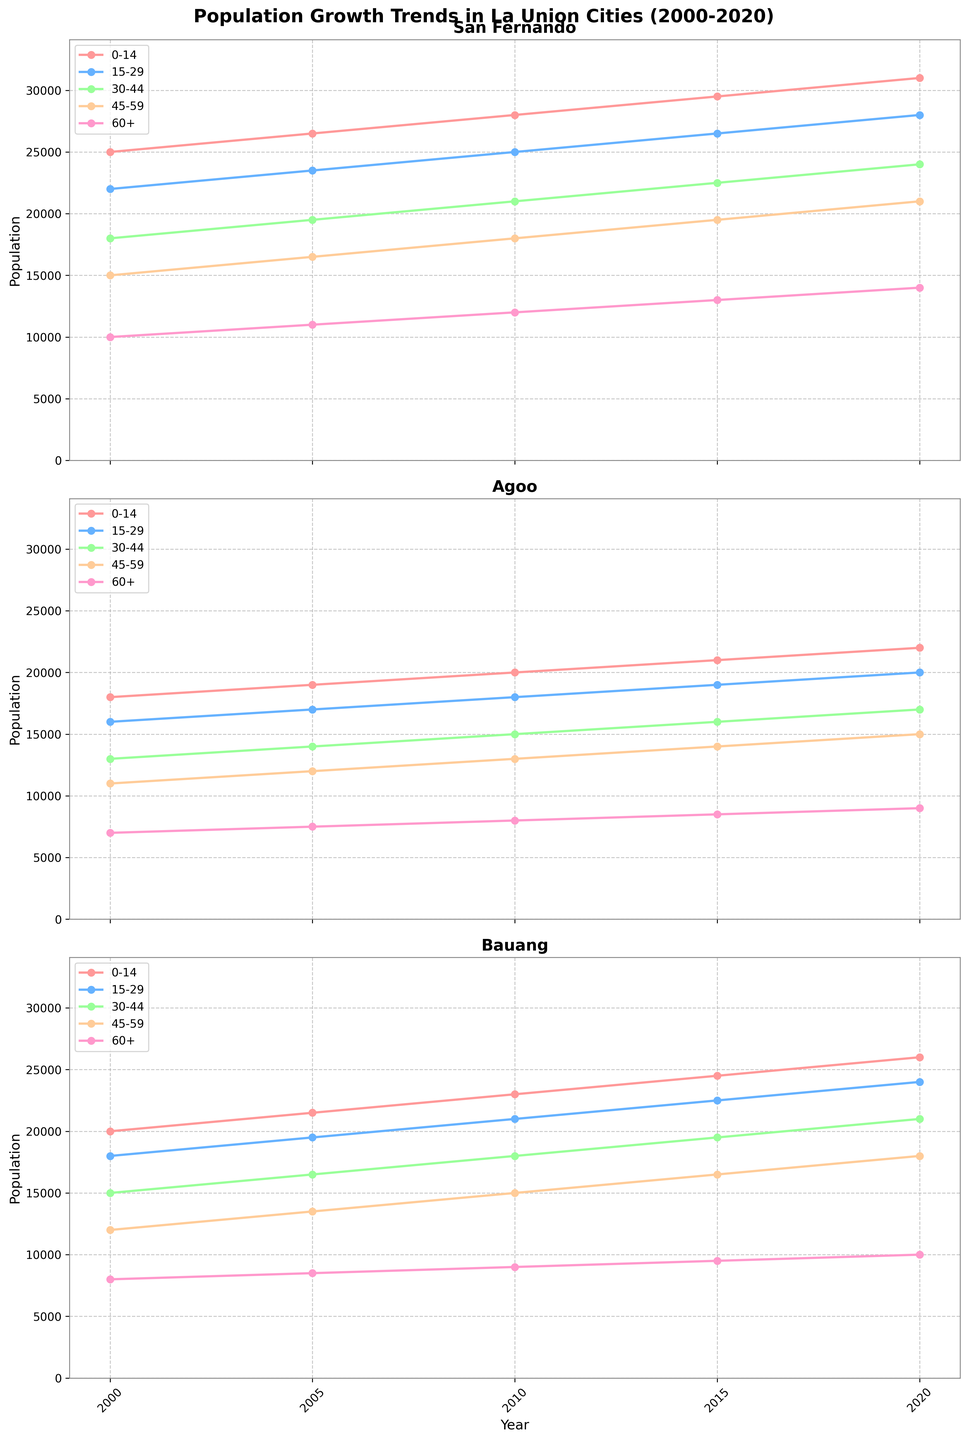How has the population of age group 15-29 in San Fernando changed from 2000 to 2020? To determine the change in population, find the population of age group 15-29 in both 2000 and 2020, and then compute the difference. The population for 15-29 age group in 2000 is 22,000. The population for 15-29 age group in 2020 is 28,000. The increase is 28,000 - 22,000 = 6,000.
Answer: 6,000 Which city had the highest population for the 0-14 age group in 2015? Look at the subplot for 2015 and compare the heights of the lines representing the 0-14 age group for all cities. San Fernando has the highest population for the 0-14 age group in 2015, with 29,500.
Answer: San Fernando For the age group 60+, compare the population growth in Agoo and Bauang from 2000 to 2020. To compare the growth, calculate the difference for each city.
- Agoo: 9,000 in 2020 and 7,000 in 2000, thus an increase of 9,000 - 7,000 = 2,000.
- Bauang: 10,000 in 2020 and 8,000 in 2000, thus an increase of 10,000 - 8,000 = 2,000.
Both cities had the same population growth.
Answer: Same Which age group in Bauang showed the greatest population increase from 2000 to 2020? Calculate the population increases for each age group in Bauang:
- 0-14: 26,000 - 20,000 = 6,000
- 15-29: 24,000 - 18,000 = 6,000
- 30-44: 21,000 - 15,000 = 6,000
- 45-59: 18,000 - 12,000 = 6,000
- 60+: 10,000 - 8,000 = 2,000
The groups 0-14, 15-29, 30-44, and 45-59 all showed the greatest increase of 6,000.
Answer: 0-14, 15-29, 30-44, and 45-59 In 2010, which city had the smallest population for age group 45-59 and what was the value? Compare the populations for the 45-59 age group in all the cities for the year 2010. Agoo had the smallest population for the 45-59 age group with 13,000.
Answer: Agoo, 13,000 How many age groups in San Fernando have populations exceeding 20,000 in 2020? Check the population values for each age group for the year 2020 in San Fernando. The age groups with populations exceeding 20,000 are 0-14, 15-29, and 30-44. Thus, there are 3 age groups.
Answer: 3 